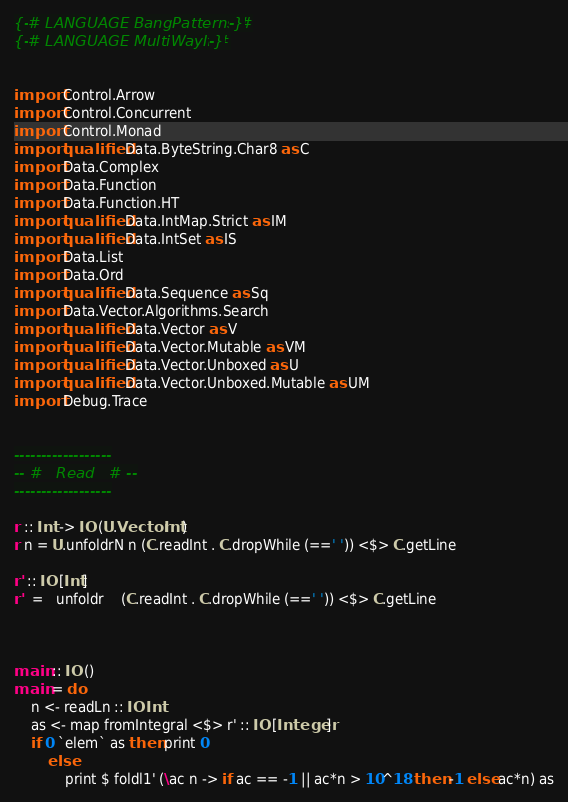Convert code to text. <code><loc_0><loc_0><loc_500><loc_500><_Haskell_>{-# LANGUAGE BangPatterns #-}
{-# LANGUAGE MultiWayIf #-}


import Control.Arrow
import Control.Concurrent
import Control.Monad
import qualified Data.ByteString.Char8 as C
import Data.Complex
import Data.Function
import Data.Function.HT
import qualified Data.IntMap.Strict as IM
import qualified Data.IntSet as IS
import Data.List
import Data.Ord
import qualified Data.Sequence as Sq
import Data.Vector.Algorithms.Search
import qualified Data.Vector as V
import qualified Data.Vector.Mutable as VM
import qualified Data.Vector.Unboxed as U
import qualified Data.Vector.Unboxed.Mutable as UM
import Debug.Trace


------------------
-- #   Read   # --
------------------

r :: Int -> IO (U.Vector Int)
r n = U.unfoldrN n (C.readInt . C.dropWhile (==' ')) <$> C.getLine

r' :: IO [Int]
r'  =   unfoldr    (C.readInt . C.dropWhile (==' ')) <$> C.getLine



main :: IO ()
main = do
    n <- readLn :: IO Int
    as <- map fromIntegral <$> r' :: IO [Integer]
    if 0 `elem` as then print 0
        else
            print $ foldl1' (\ac n -> if ac == -1 || ac*n > 10^18 then -1 else ac*n) as
</code> 